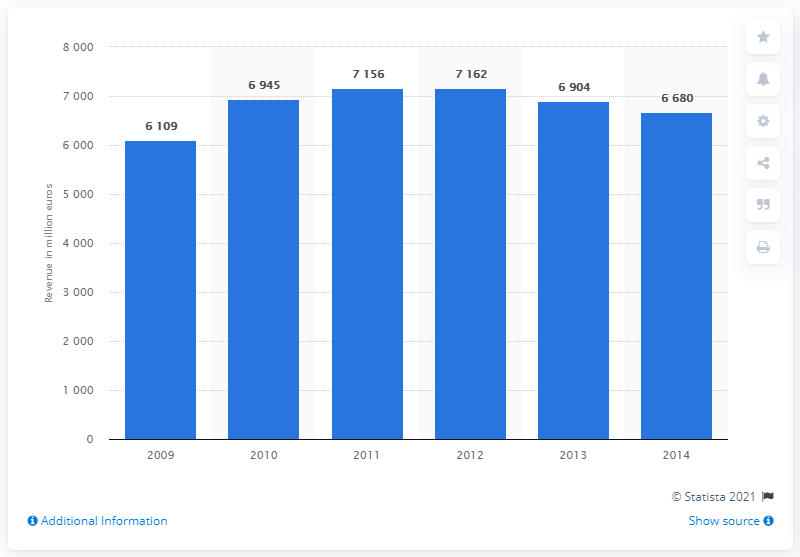Mention a couple of crucial points in this snapshot. In 2009, TNT Express NV reported its worldwide revenue for the first time. In 2014, TNT Express NV's worldwide revenue came to an end. 